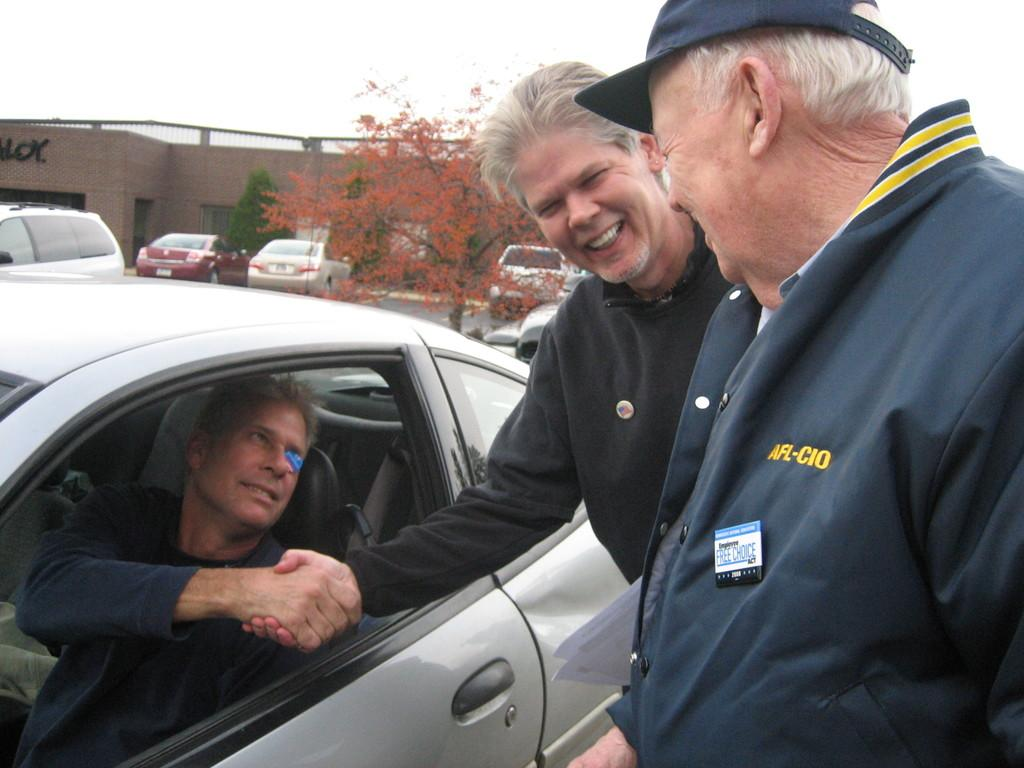What is the person in the image doing? There is a person in a car in the image. What are the two men on the right side of the image doing? The two men are standing and laughing. What can be seen in the background of the image? There is a building, vehicles, a tree, and the sky visible in the background of the image. What type of hole can be seen in the image? There is no hole present in the image. Where is the office located in the image? There is no office present in the image. 